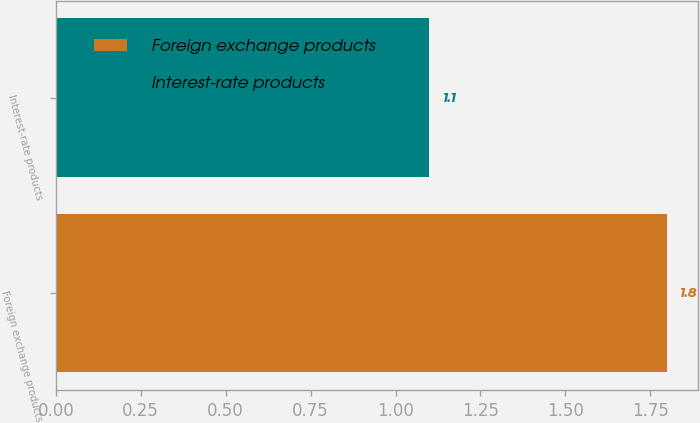Convert chart to OTSL. <chart><loc_0><loc_0><loc_500><loc_500><bar_chart><fcel>Foreign exchange products<fcel>Interest-rate products<nl><fcel>1.8<fcel>1.1<nl></chart> 